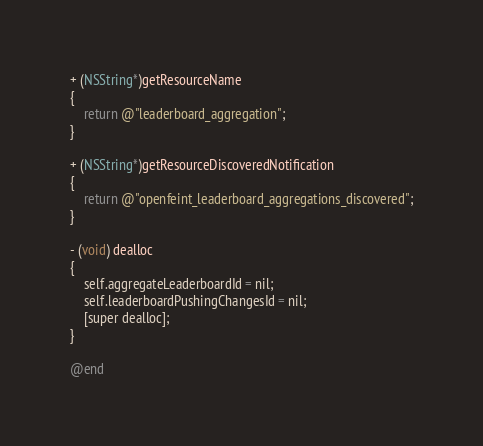<code> <loc_0><loc_0><loc_500><loc_500><_ObjectiveC_>
+ (NSString*)getResourceName
{
	return @"leaderboard_aggregation";
}

+ (NSString*)getResourceDiscoveredNotification
{
	return @"openfeint_leaderboard_aggregations_discovered";
}

- (void) dealloc
{
	self.aggregateLeaderboardId = nil;
	self.leaderboardPushingChangesId = nil;
	[super dealloc];
}

@end
</code> 